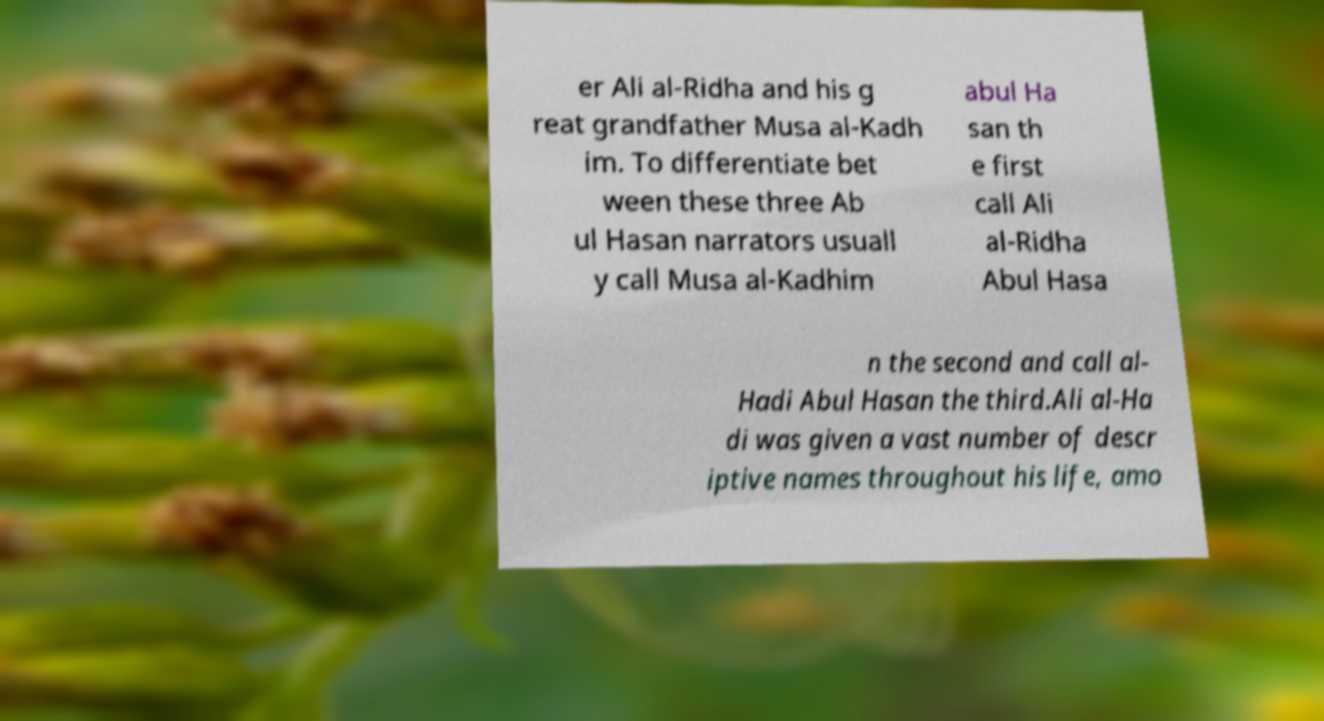Could you extract and type out the text from this image? er Ali al-Ridha and his g reat grandfather Musa al-Kadh im. To differentiate bet ween these three Ab ul Hasan narrators usuall y call Musa al-Kadhim abul Ha san th e first call Ali al-Ridha Abul Hasa n the second and call al- Hadi Abul Hasan the third.Ali al-Ha di was given a vast number of descr iptive names throughout his life, amo 